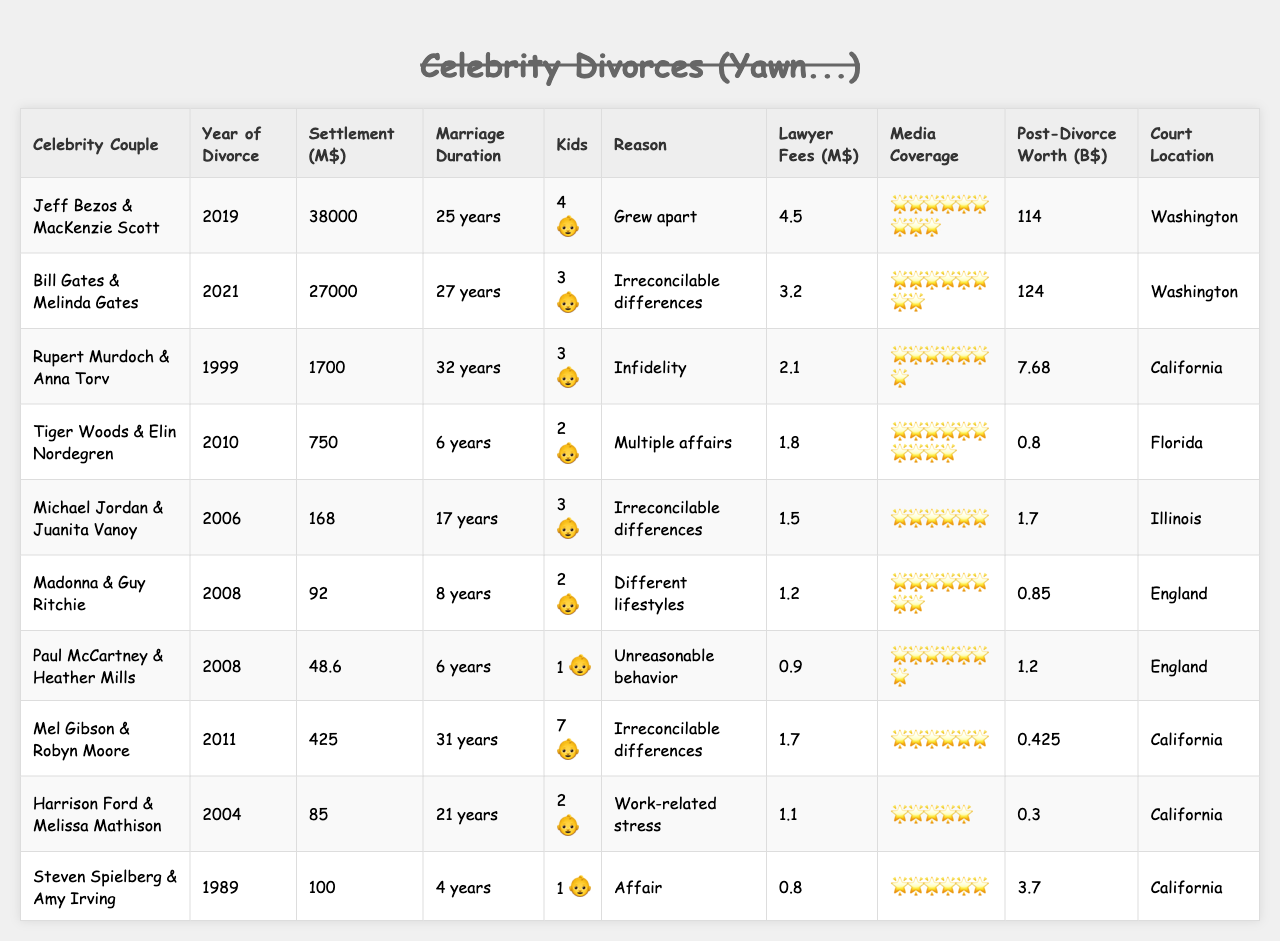What is the highest divorce settlement amount listed? The table shows the settlement amounts for each celebrity divorce. Scanning through the "Settlement Amount (Millions USD)" column, the highest amount is for Jeff Bezos & MacKenzie Scott at 38,000 million USD.
Answer: 38,000 million USD Which couple had the shortest marriage duration? Looking at the "Marriage Duration (Years)" column, the couple with the shortest duration is Steven Spielberg & Amy Irving, who were married for 4 years.
Answer: 4 years What is the average settlement amount of the divorces listed? To calculate the average, add all the settlement amounts: (38,000 + 27,000 + 1,700 + 750 + 168 + 92 + 48.6 + 425 + 85 + 100) = 67,368.6 million USD. There are 10 couples, so the average is 67,368.6 / 10 = 6,736.86 million USD.
Answer: 6,736.86 million USD Is there a couple with a settlement less than 100 million USD? Checking the "Settlement Amount (Millions USD)" column, there are several couples with amounts under 100 million USD such as Madonna & Guy Ritchie (48.6 million USD), Mel Gibson & Robyn Moore (425 million USD), and others.
Answer: Yes How many children do Jeff Bezos and MacKenzie Scott have? The "Number of Children" column specifies that Jeff Bezos & MacKenzie Scott have 4 children.
Answer: 4 children Which couple had the most media coverage? The "Media Coverage Score (1-10)" column shows the scores. Tiger Woods & Elin Nordegren received a perfect score of 10, indicating they had the most media coverage.
Answer: Tiger Woods & Elin Nordegren Are there any couples who divorced for "irreconcilable differences"? By reviewing the "Reason for Divorce" column, both Bill Gates & Melinda Gates and Michael Jordan & Juanita Vanoy divorced for "irreconcilable differences."
Answer: Yes What is the difference in settlement amounts between the highest and lowest settlements? The highest settlement amount is 38,000 million USD (Jeff Bezos & MacKenzie Scott) and the lowest is 48.6 million USD (Madonna & Guy Ritchie). The difference is 38,000 - 48.6 = 37,951.4 million USD.
Answer: 37,951.4 million USD Which divorce occurred in the year 2008, and what was the settlement amount? Scanning the "Year of Divorce" column, the couples that divorced in 2008 are Madonna & Guy Ritchie and Paul McCartney & Heather Mills. Their settlements were 48.6 million USD and 92 million USD, respectively.
Answer: Madonna & Guy Ritchie: 48.6 million USD; Paul McCartney & Heather Mills: 92 million USD What was the post-divorce net worth of Bill Gates? The "Post-Divorce Net Worth (Billions USD)" column indicates that Bill Gates had a net worth of 124 billion USD after his divorce.
Answer: 124 billion USD 